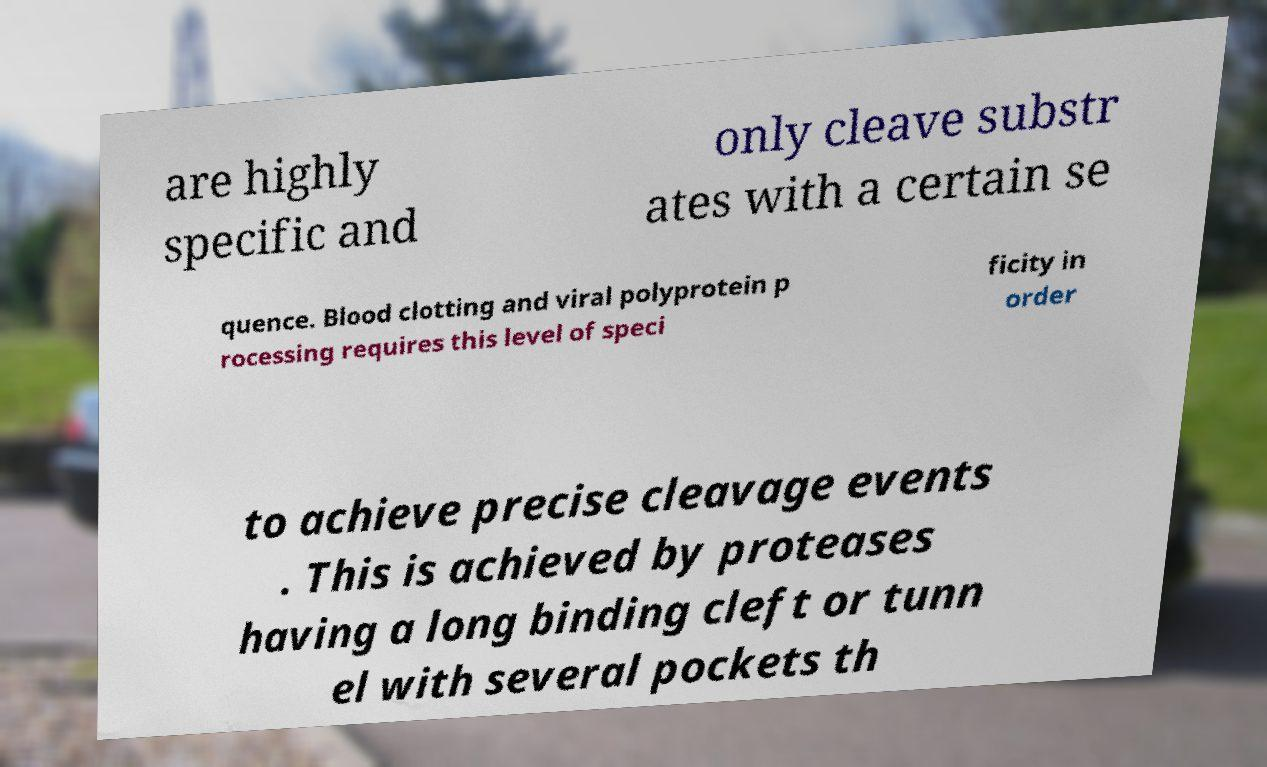I need the written content from this picture converted into text. Can you do that? are highly specific and only cleave substr ates with a certain se quence. Blood clotting and viral polyprotein p rocessing requires this level of speci ficity in order to achieve precise cleavage events . This is achieved by proteases having a long binding cleft or tunn el with several pockets th 